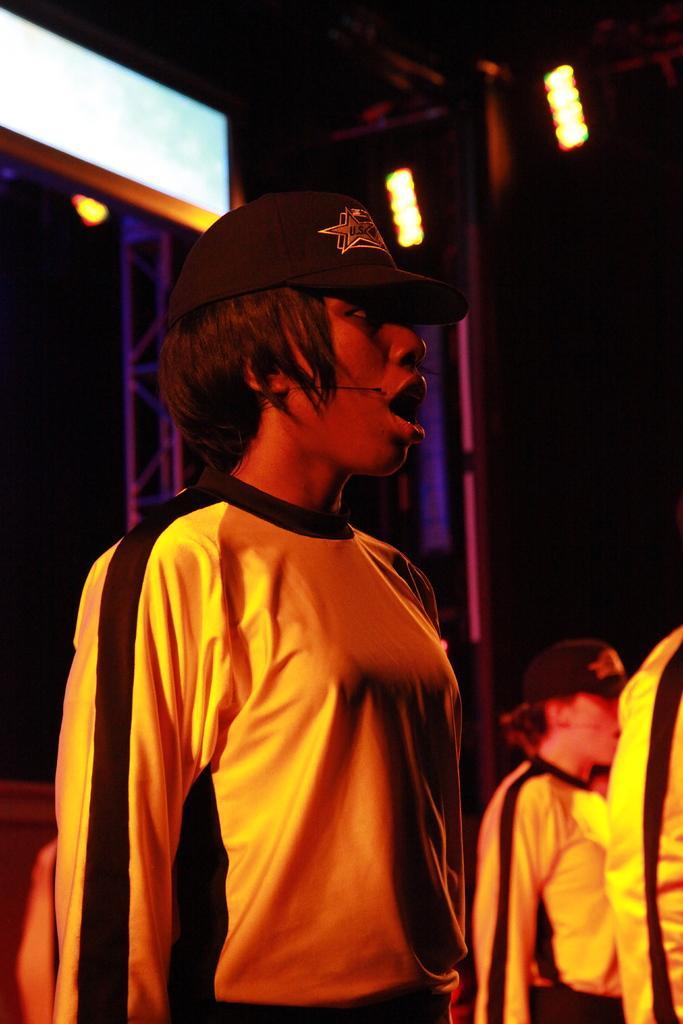Can you describe this image briefly? People are standing wearing yellow t shirt and black cap. There are lights on the top. 